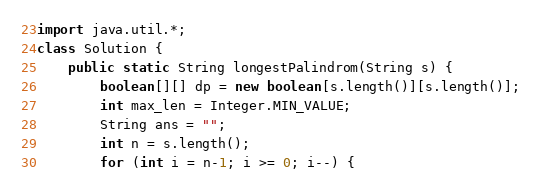Convert code to text. <code><loc_0><loc_0><loc_500><loc_500><_Java_>import java.util.*;
class Solution {
    public static String longestPalindrom(String s) {
        boolean[][] dp = new boolean[s.length()][s.length()];
        int max_len = Integer.MIN_VALUE;
        String ans = "";
        int n = s.length();
        for (int i = n-1; i >= 0; i--) {</code> 